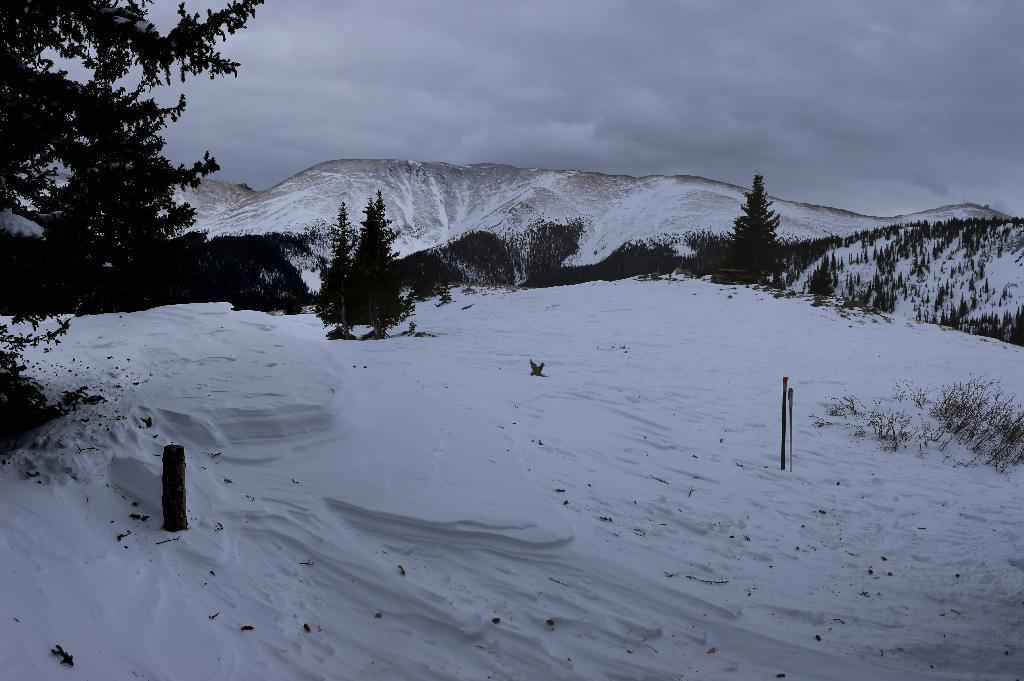In one or two sentences, can you explain what this image depicts? In this image, I can see the snowy mountains. These are the trees with branches and leaves. This is the snow. Here is the sky. 